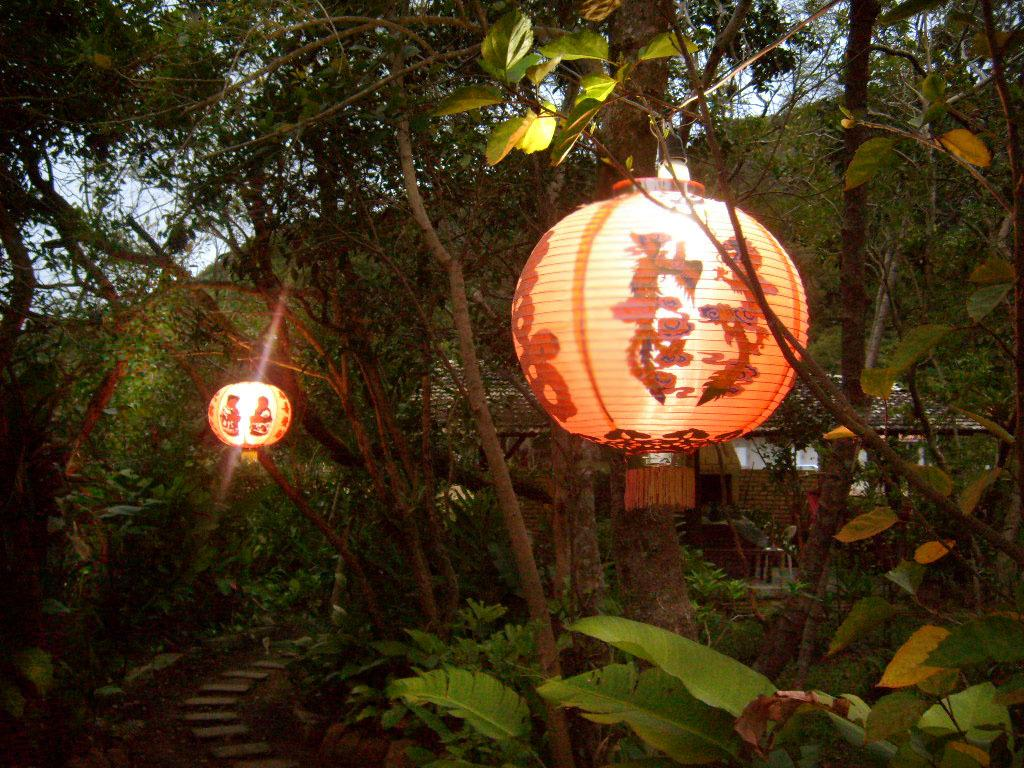What can be seen in the center of the image? The sky is visible in the center of the image. What type of natural elements are present in the image? There are trees in the image. What type of structure is visible in the image? There is a house in the image. What type of lighting is present in the image? Lanterns are present in the image. What other objects can be seen in the image? There are a few other objects in the image. Can you see a fireman playing a game with a rat in the image? No, there is no fireman, game, or rat present in the image. 